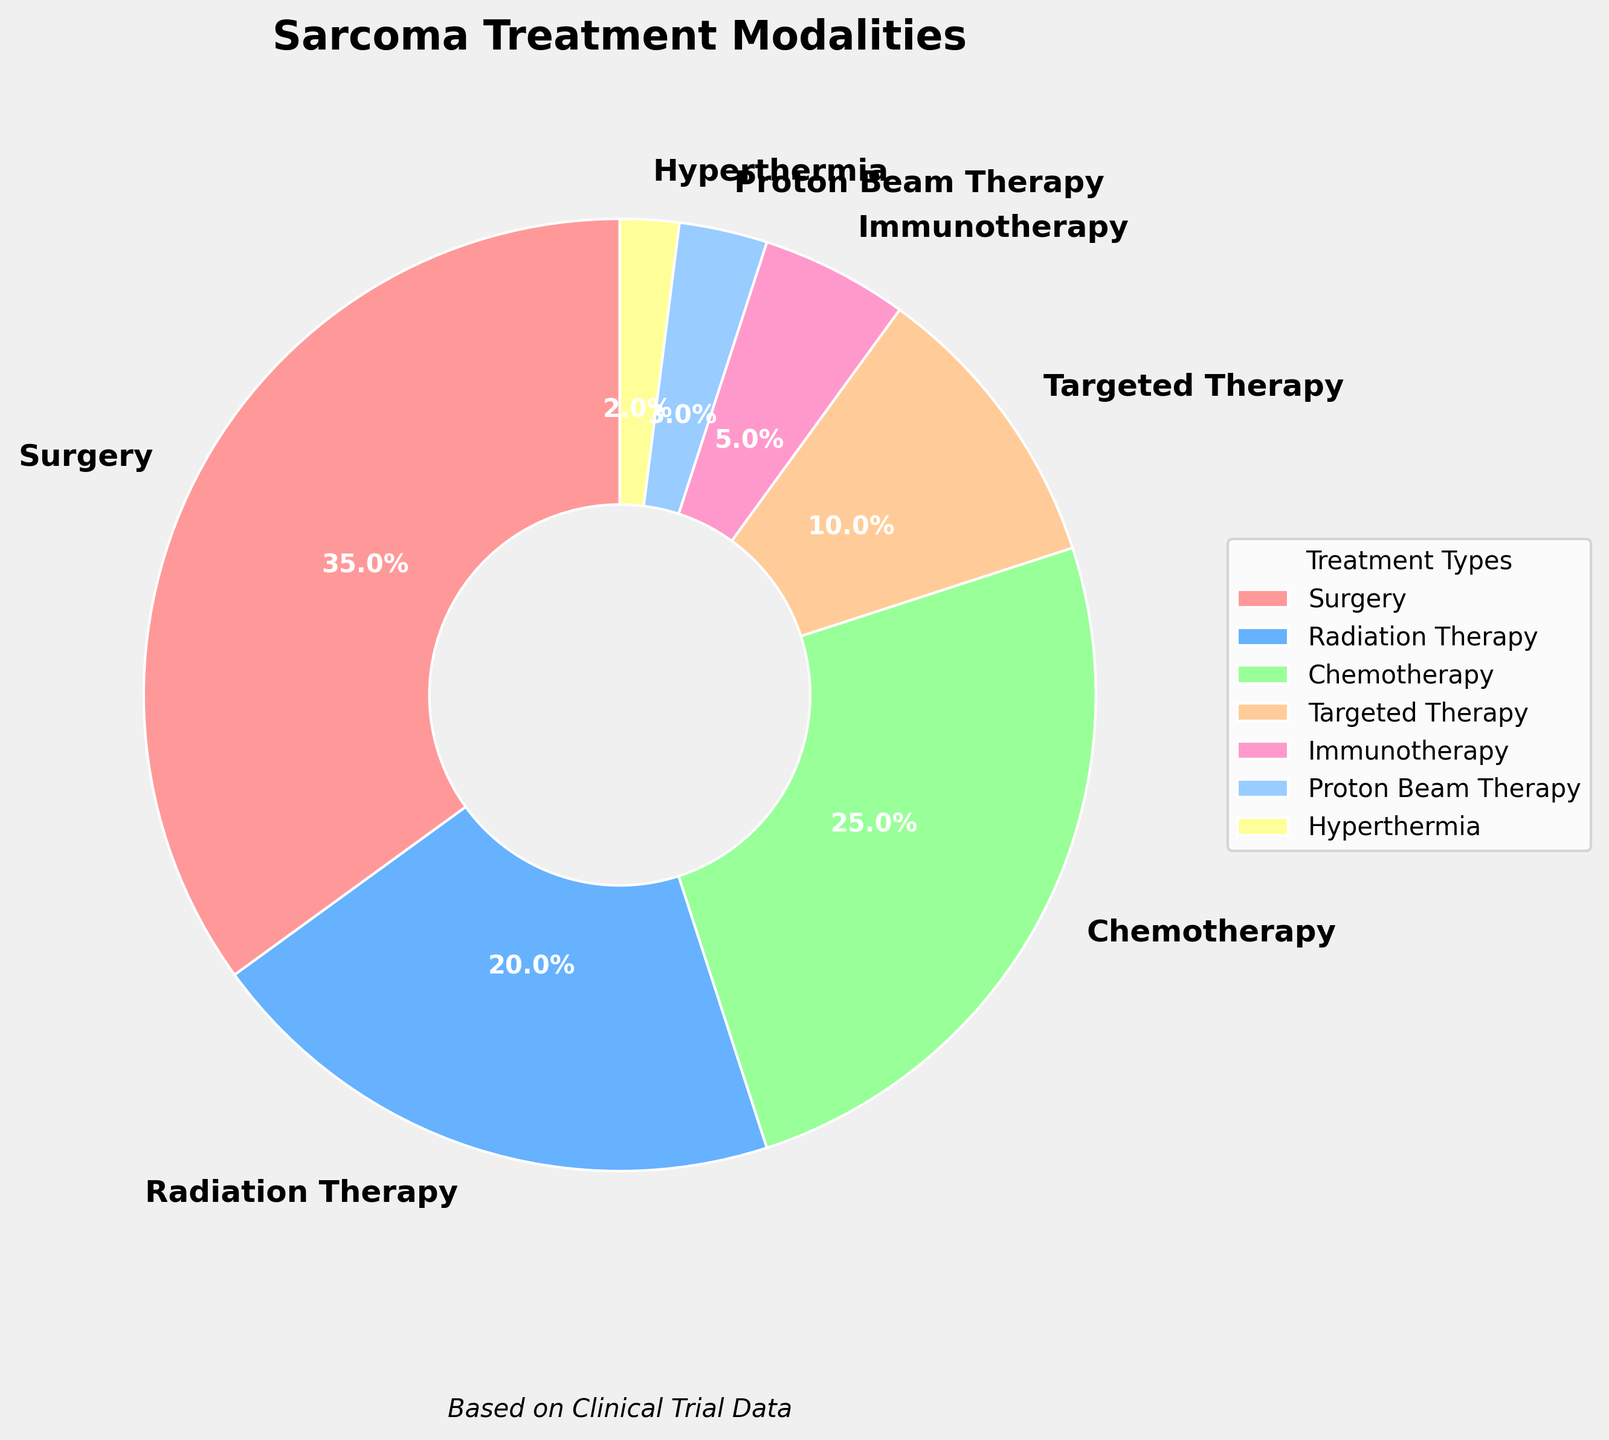What are the top three treatment modalities used for sarcoma patients based on percentage? To find the top three treatment modalities, we need to compare the percentages and pick the three highest values. The top three are 35% (Surgery), 25% (Chemotherapy), and 20% (Radiation Therapy).
Answer: Surgery, Chemotherapy, Radiation Therapy Which treatment modality has the lowest usage percentage? By comparing the percentages, we see that Hyperthermia has the lowest percentage at 2%.
Answer: Hyperthermia How much more frequently is Surgery used compared to Immunotherapy? Surgery is used 35% of the time, and Immunotherapy is used 5% of the time. Therefore, Surgery is used 35% - 5% = 30% more frequently than Immunotherapy.
Answer: 30% What is the combined percentage of Proton Beam Therapy and Hyperthermia? Proton Beam Therapy has a percentage of 3%, and Hyperthermia has a percentage of 2%. Therefore, their combined percentage is 3% + 2% = 5%.
Answer: 5% If you combine the percentages of Radiation Therapy and Chemotherapy, do they surpass the percentage of Surgery? Radiation Therapy is 20%, and Chemotherapy is 25%. Their combined percentage is 20% + 25% = 45%, which is higher than the 35% for Surgery.
Answer: Yes What fraction of the total treatments is accounted for by Targeted Therapy and Immunotherapy together? Targeted Therapy is 10%, and Immunotherapy is 5%. Their combined percentage is 10% + 5% = 15%, which is 15/100 or 3/20 of the total.
Answer: 3/20 Which has a higher percentage, Proton Beam Therapy or Hyperthermia? Proton Beam Therapy has 3%, and Hyperthermia has 2%. Therefore, Proton Beam Therapy has a higher percentage.
Answer: Proton Beam Therapy Which treatment modality is represented by the second-largest segment in the pie chart? From the percentages provided, we identify the segments. Surgery is the largest (35%), and Chemotherapy is the second largest (25%).
Answer: Chemotherapy What is the difference in percentage between the least used and the most used treatment modalities? The most used modality is Surgery at 35%, and the least used is Hyperthermia at 2%. The difference is 35% - 2% = 33%.
Answer: 33% How do the percentages of Radiation Therapy and Targeted Therapy compare? Radiation Therapy is 20%, and Targeted Therapy is 10%. Radiation Therapy, therefore, has a higher percentage.
Answer: Radiation Therapy 